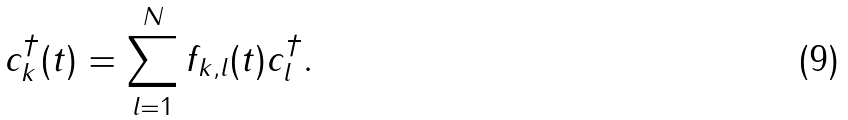Convert formula to latex. <formula><loc_0><loc_0><loc_500><loc_500>c _ { k } ^ { \dagger } ( t ) = \sum _ { l = 1 } ^ { N } f _ { k , l } ( t ) c _ { l } ^ { \dagger } .</formula> 